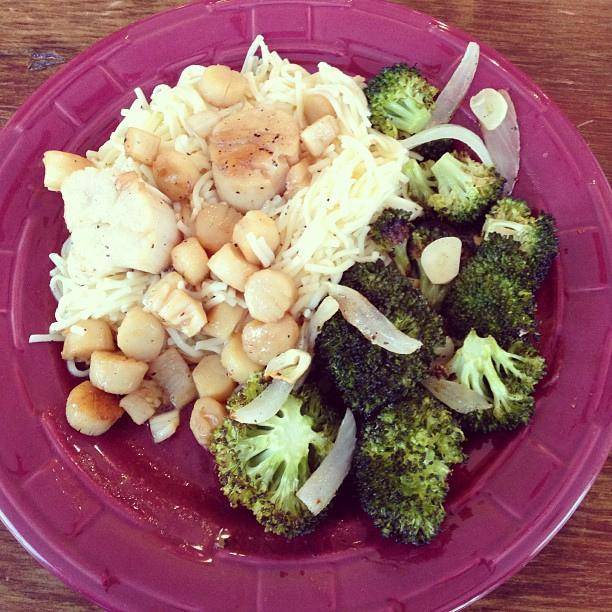What type of seafood is being served? scallops 